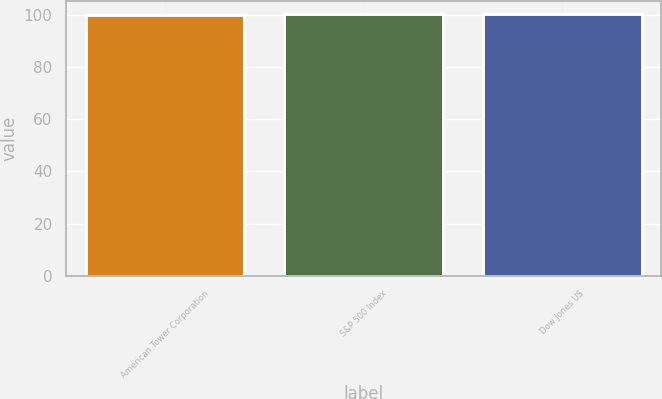Convert chart to OTSL. <chart><loc_0><loc_0><loc_500><loc_500><bar_chart><fcel>American Tower Corporation<fcel>S&P 500 Index<fcel>Dow Jones US<nl><fcel>100<fcel>100.1<fcel>100.2<nl></chart> 